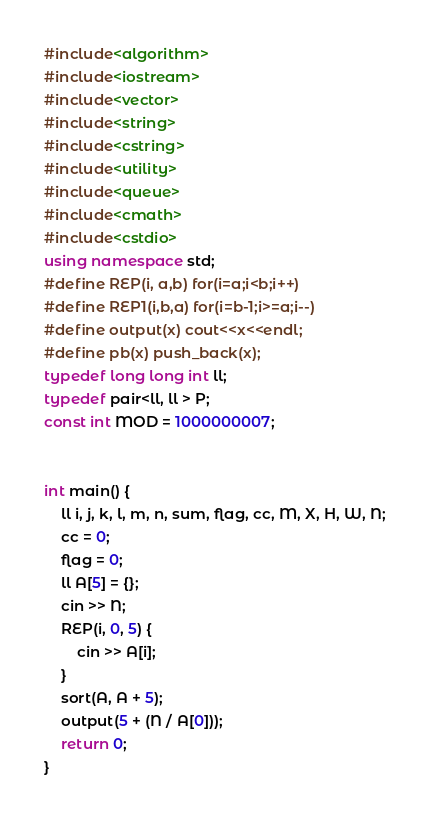Convert code to text. <code><loc_0><loc_0><loc_500><loc_500><_C++_>
#include<algorithm>
#include<iostream>
#include<vector>
#include<string>
#include<cstring>
#include<utility>
#include<queue>
#include<cmath>
#include<cstdio>
using namespace std;
#define REP(i, a,b) for(i=a;i<b;i++) 
#define REP1(i,b,a) for(i=b-1;i>=a;i--)
#define output(x) cout<<x<<endl;
#define pb(x) push_back(x);
typedef long long int ll;
typedef pair<ll, ll > P;
const int MOD = 1000000007;


int main() {
	ll i, j, k, l, m, n, sum, flag, cc, M, X, H, W, N;
	cc = 0;
	flag = 0;
	ll A[5] = {};
	cin >> N;
	REP(i, 0, 5) {
		cin >> A[i];
	}
	sort(A, A + 5);
	output(5 + (N / A[0]));
	return 0;
}



</code> 